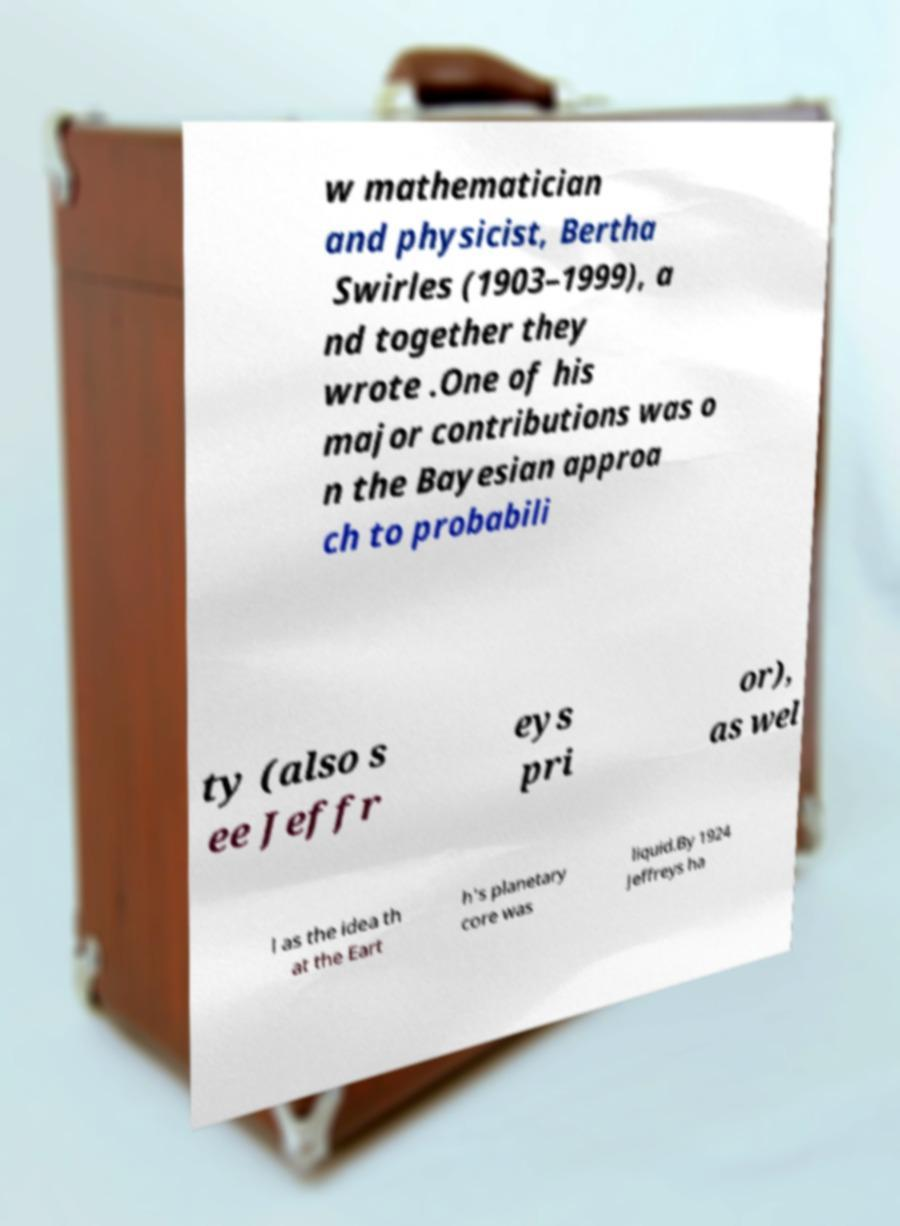Could you assist in decoding the text presented in this image and type it out clearly? w mathematician and physicist, Bertha Swirles (1903–1999), a nd together they wrote .One of his major contributions was o n the Bayesian approa ch to probabili ty (also s ee Jeffr eys pri or), as wel l as the idea th at the Eart h's planetary core was liquid.By 1924 Jeffreys ha 